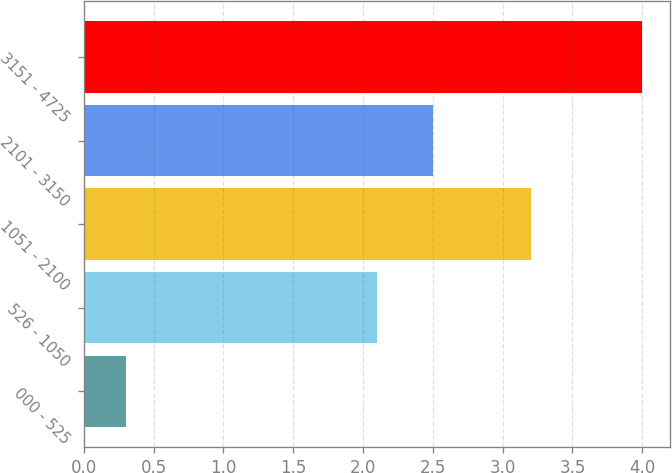Convert chart to OTSL. <chart><loc_0><loc_0><loc_500><loc_500><bar_chart><fcel>000 - 525<fcel>526 - 1050<fcel>1051 - 2100<fcel>2101 - 3150<fcel>3151 - 4725<nl><fcel>0.3<fcel>2.1<fcel>3.2<fcel>2.5<fcel>4<nl></chart> 